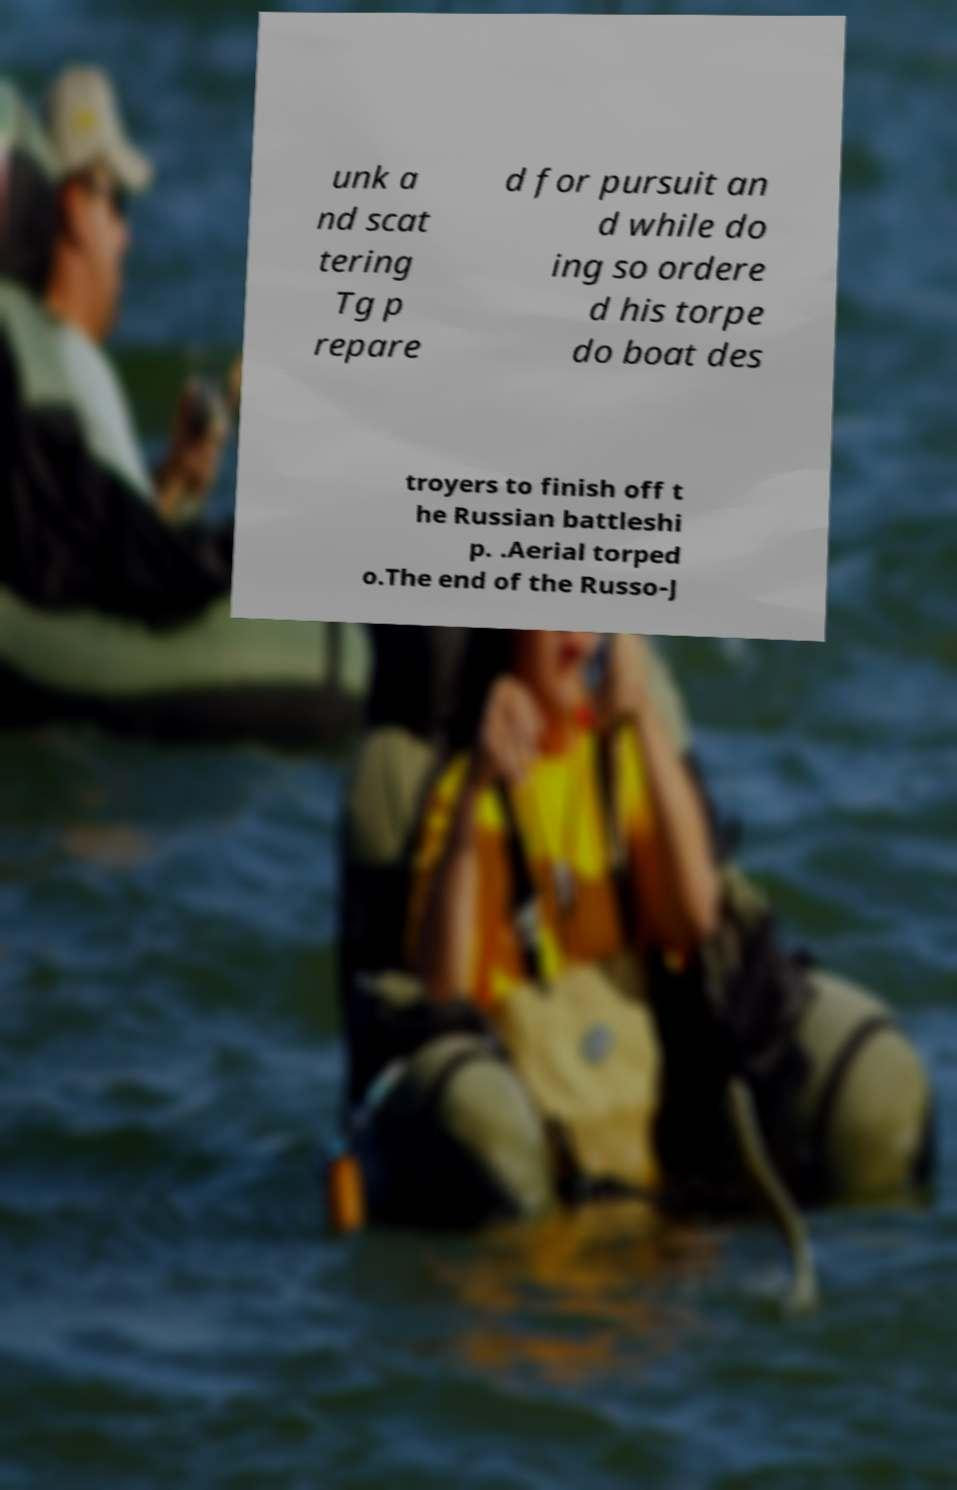Could you assist in decoding the text presented in this image and type it out clearly? unk a nd scat tering Tg p repare d for pursuit an d while do ing so ordere d his torpe do boat des troyers to finish off t he Russian battleshi p. .Aerial torped o.The end of the Russo-J 